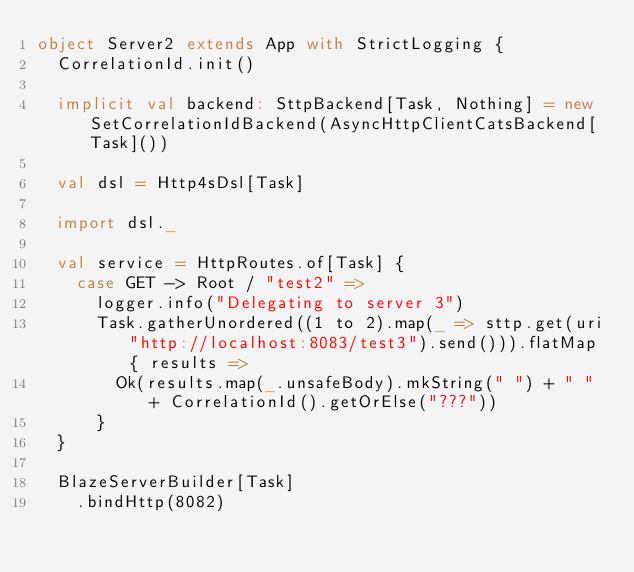<code> <loc_0><loc_0><loc_500><loc_500><_Scala_>object Server2 extends App with StrictLogging {
  CorrelationId.init()

  implicit val backend: SttpBackend[Task, Nothing] = new SetCorrelationIdBackend(AsyncHttpClientCatsBackend[Task]())

  val dsl = Http4sDsl[Task]

  import dsl._

  val service = HttpRoutes.of[Task] {
    case GET -> Root / "test2" =>
      logger.info("Delegating to server 3")
      Task.gatherUnordered((1 to 2).map(_ => sttp.get(uri"http://localhost:8083/test3").send())).flatMap { results =>
        Ok(results.map(_.unsafeBody).mkString(" ") + " " + CorrelationId().getOrElse("???"))
      }
  }

  BlazeServerBuilder[Task]
    .bindHttp(8082)</code> 